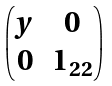<formula> <loc_0><loc_0><loc_500><loc_500>\begin{pmatrix} y & 0 \\ 0 & 1 _ { 2 2 } \end{pmatrix}</formula> 